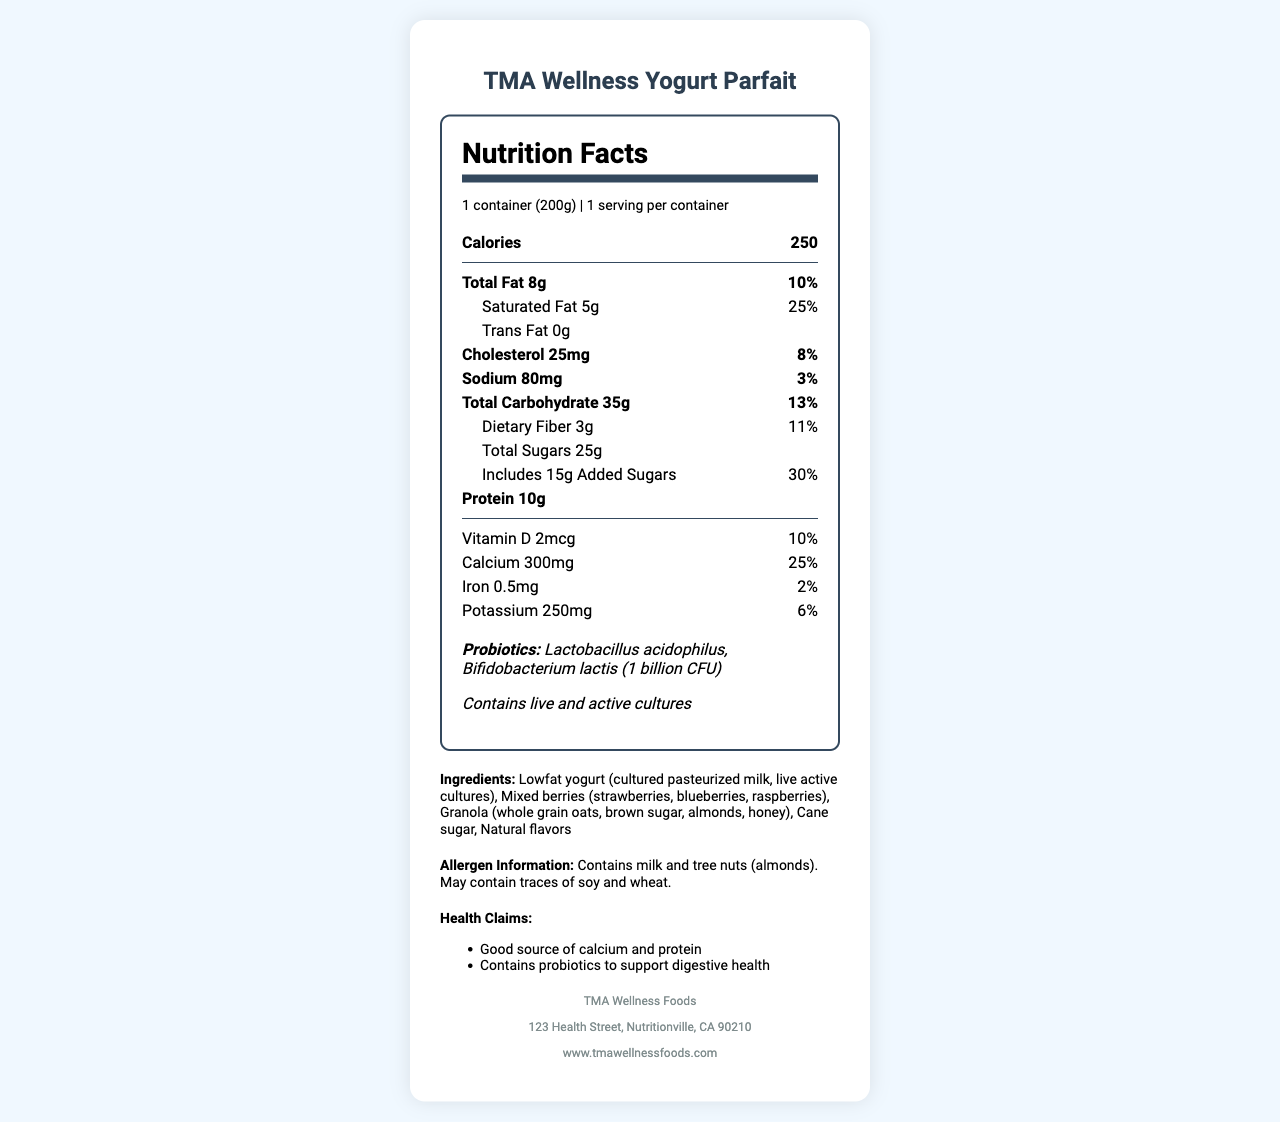What is the calorie content per serving? The main section of the nutrition label lists 250 calories per serving.
Answer: 250 Name two probiotic strains present in the yogurt parfait. The probiotics section states "Lactobacillus acidophilus, Bifidobacterium lactis."
Answer: Lactobacillus acidophilus and Bifidobacterium lactis What percentage of the daily value of saturated fat does one serving contain? The saturated fat content is listed as 5g, which corresponds to 25% of the daily value.
Answer: 25% How much added sugar is in one serving of the yogurt parfait? The nutrition label specifies "Includes 15g Added Sugars."
Answer: 15g Which ingredient in the yogurt parfait may cause allergies? The allergen information states "Contains milk and tree nuts (almonds)."
Answer: Milk and tree nuts (almonds) What is the daily value percentage of calcium provided by one serving? The calcium content is listed as 300mg, which equates to 25% of the daily value.
Answer: 25% How many grams of total fat does the yogurt parfait have? The nutrition label specifies that the total fat content is 8g.
Answer: 8g Does the yogurt parfait contain any trans fat? The nutrition label states "Trans Fat 0g."
Answer: No Which of the following is not an ingredient in the TMA Wellness Yogurt Parfait? A. Mixed berries B. Cane sugar C. Artificial flavors D. Whole grain oats The ingredient list includes mixed berries, cane sugar, and whole grain oats, but not artificial flavors.
Answer: C. Artificial flavors What is the serving size of the TMA Wellness Yogurt Parfait? A. 150g B. 200g C. 250g D. 300g The nutrition label specifies a serving size of "1 container (200g)."
Answer: B. 200g Is TMA Wellness Yogurt Parfait a good source of protein? One of the health claims is "Good source of calcium and protein."
Answer: Yes Summarize the TMA Wellness Yogurt Parfait nutrition label. This summary provides an overview of all key nutritional components, ingredients, health claims, and allergen information of the yogurt parfait.
Answer: The TMA Wellness Yogurt Parfait has 250 calories per serving, with 8g of total fat, 5g of saturated fat, 0g of trans fat, 25mg of cholesterol, 80mg of sodium, 35g of total carbohydrate, 3g of dietary fiber, 25g of total sugars (including 15g of added sugars), and 10g of protein. It contains significant amounts of vitamin D, calcium, iron, and potassium. The yogurt parfait includes probiotics (Lactobacillus acidophilus, Bifidobacterium lactis) with health claims supporting calcium, protein, and digestive health. Ingredients consist of lowfat yogurt, mixed berries, granola, cane sugar, and natural flavors. It contains allergens like milk and almonds, with potential traces of soy and wheat. What is the exact address of TMA Wellness Foods? The company information section lists the address as "123 Health Street, Nutritionville, CA 90210."
Answer: 123 Health Street, Nutritionville, CA 90210 How old is the company TMA Wellness Foods? The document does not provide any information related to the age or the founding year of TMA Wellness Foods.
Answer: I don't know 